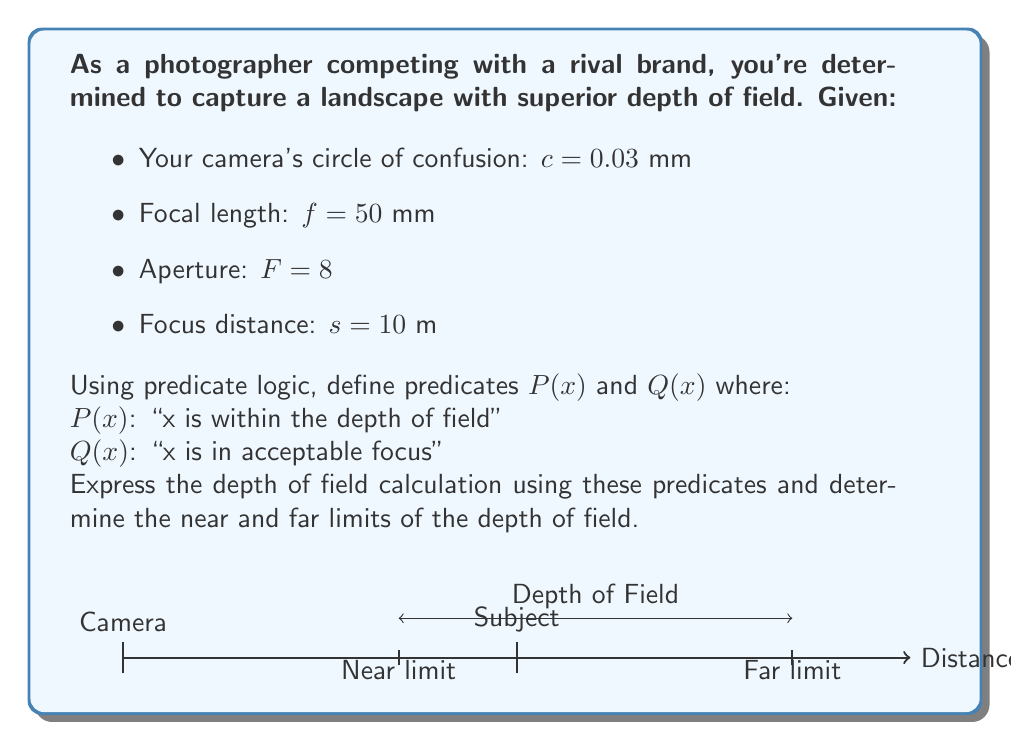Give your solution to this math problem. Let's approach this step-by-step using predicate logic and the depth of field formula:

1) First, we define our predicates:
   $P(x)$: "x is within the depth of field"
   $Q(x)$: "x is in acceptable focus"

2) We can express the relationship between these predicates as:
   $\forall x(P(x) \implies Q(x))$

3) To calculate the depth of field, we need to find the near limit ($D_n$) and far limit ($D_f$):

   $D_n = \frac{s(H-f)}{H+s-2f}$
   $D_f = \frac{s(H-f)}{H-s}$

   Where $H$ is the hyperfocal distance: $H = \frac{f^2}{Fc} + f$

4) Calculate $H$:
   $H = \frac{50^2}{8 \cdot 0.03} + 50 = 10416.67$ mm $\approx 10.42$ m

5) Calculate $D_n$:
   $D_n = \frac{10(10.42-0.05)}{10.42+10-2(0.05)} = 5.13$ m

6) Calculate $D_f$:
   $D_f = \frac{10(10.42-0.05)}{10.42-10} = 247.62$ m

7) Now we can express our depth of field in predicate logic:
   $\forall x((5.13 \leq x \leq 247.62) \implies P(x))$

8) And combining with our initial statement:
   $\forall x((5.13 \leq x \leq 247.62) \implies P(x)) \land \forall x(P(x) \implies Q(x))$

This logical statement expresses that all distances between 5.13 m and 247.62 m are within the depth of field, and all points within the depth of field are in acceptable focus.
Answer: $\forall x((5.13 \leq x \leq 247.62) \implies P(x)) \land \forall x(P(x) \implies Q(x))$ 